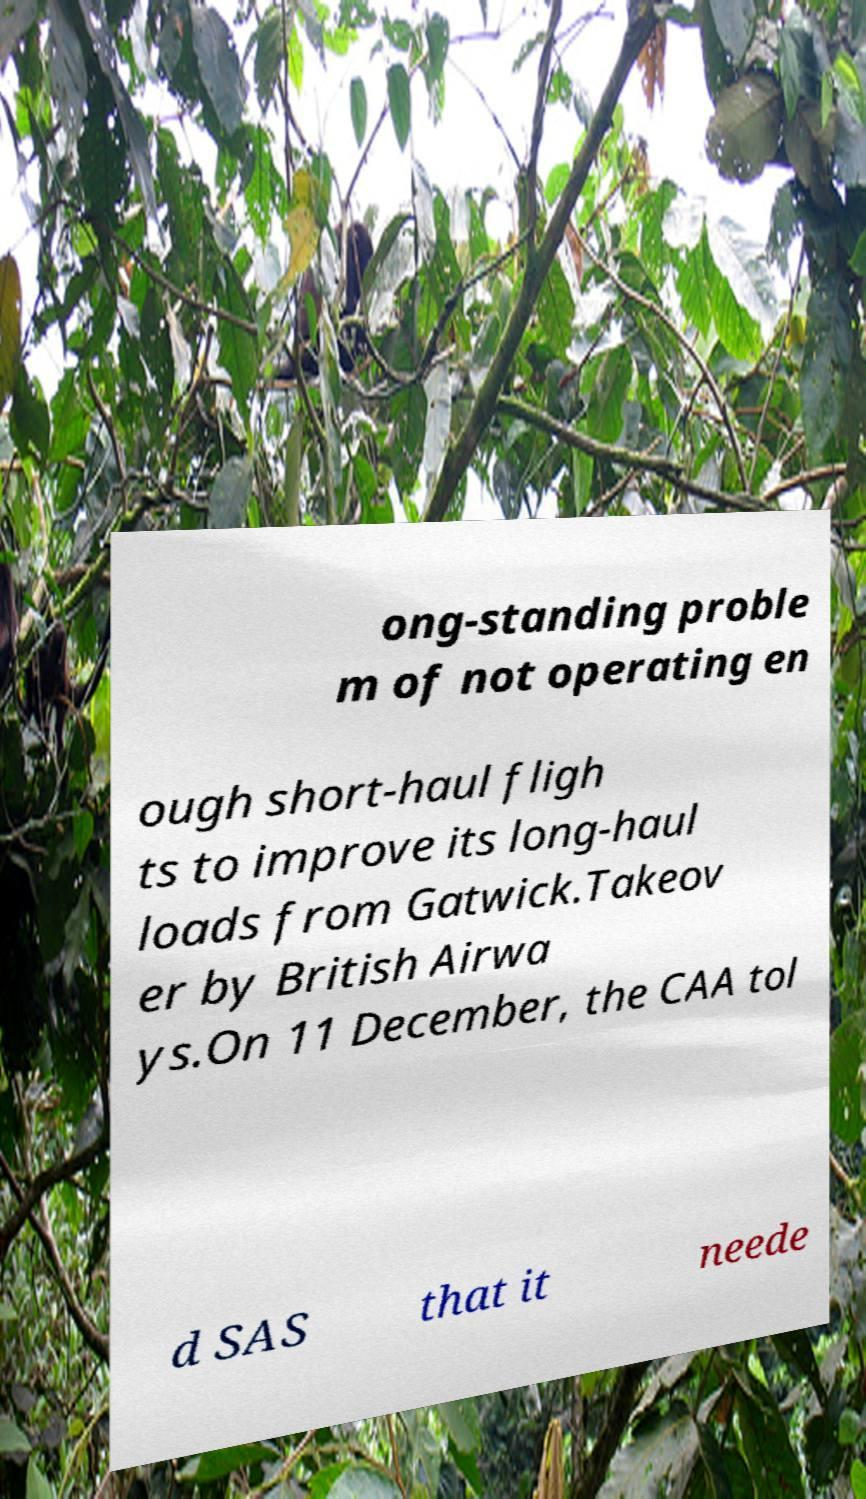Please identify and transcribe the text found in this image. ong-standing proble m of not operating en ough short-haul fligh ts to improve its long-haul loads from Gatwick.Takeov er by British Airwa ys.On 11 December, the CAA tol d SAS that it neede 